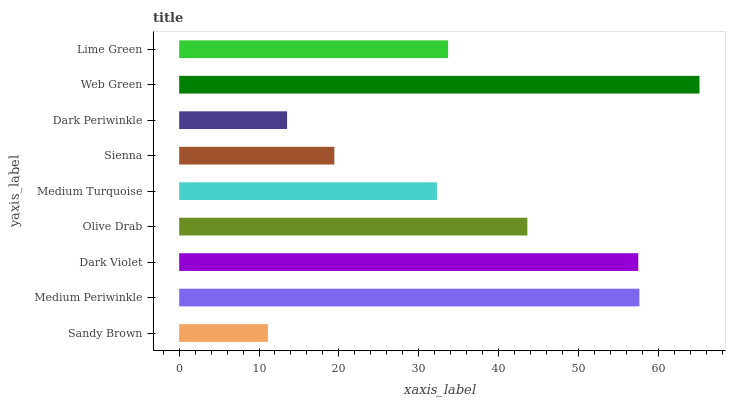Is Sandy Brown the minimum?
Answer yes or no. Yes. Is Web Green the maximum?
Answer yes or no. Yes. Is Medium Periwinkle the minimum?
Answer yes or no. No. Is Medium Periwinkle the maximum?
Answer yes or no. No. Is Medium Periwinkle greater than Sandy Brown?
Answer yes or no. Yes. Is Sandy Brown less than Medium Periwinkle?
Answer yes or no. Yes. Is Sandy Brown greater than Medium Periwinkle?
Answer yes or no. No. Is Medium Periwinkle less than Sandy Brown?
Answer yes or no. No. Is Lime Green the high median?
Answer yes or no. Yes. Is Lime Green the low median?
Answer yes or no. Yes. Is Dark Periwinkle the high median?
Answer yes or no. No. Is Medium Periwinkle the low median?
Answer yes or no. No. 